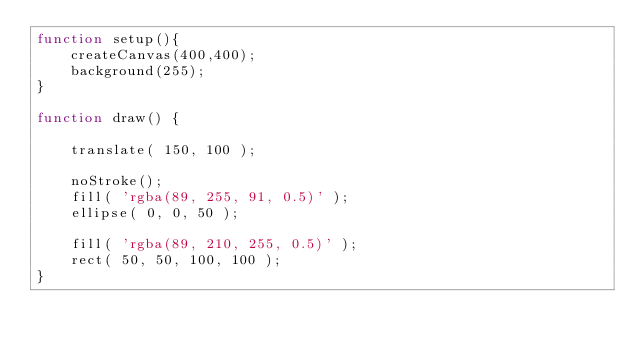Convert code to text. <code><loc_0><loc_0><loc_500><loc_500><_JavaScript_>function setup(){
    createCanvas(400,400);
    background(255);
}

function draw() {

    translate( 150, 100 );

    noStroke();
    fill( 'rgba(89, 255, 91, 0.5)' );
    ellipse( 0, 0, 50 );

    fill( 'rgba(89, 210, 255, 0.5)' );
    rect( 50, 50, 100, 100 );
}
</code> 